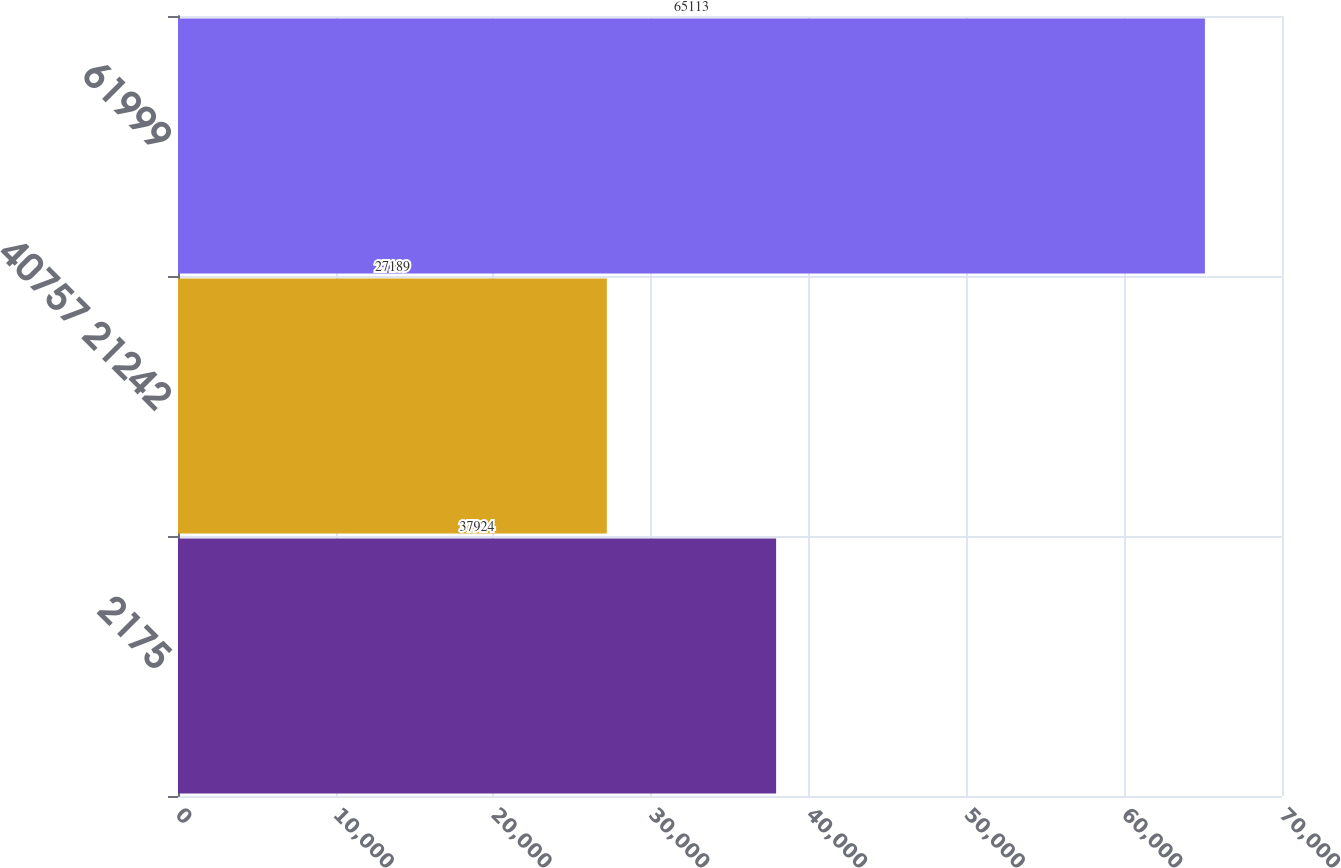Convert chart. <chart><loc_0><loc_0><loc_500><loc_500><bar_chart><fcel>2175<fcel>40757 21242<fcel>61999<nl><fcel>37924<fcel>27189<fcel>65113<nl></chart> 